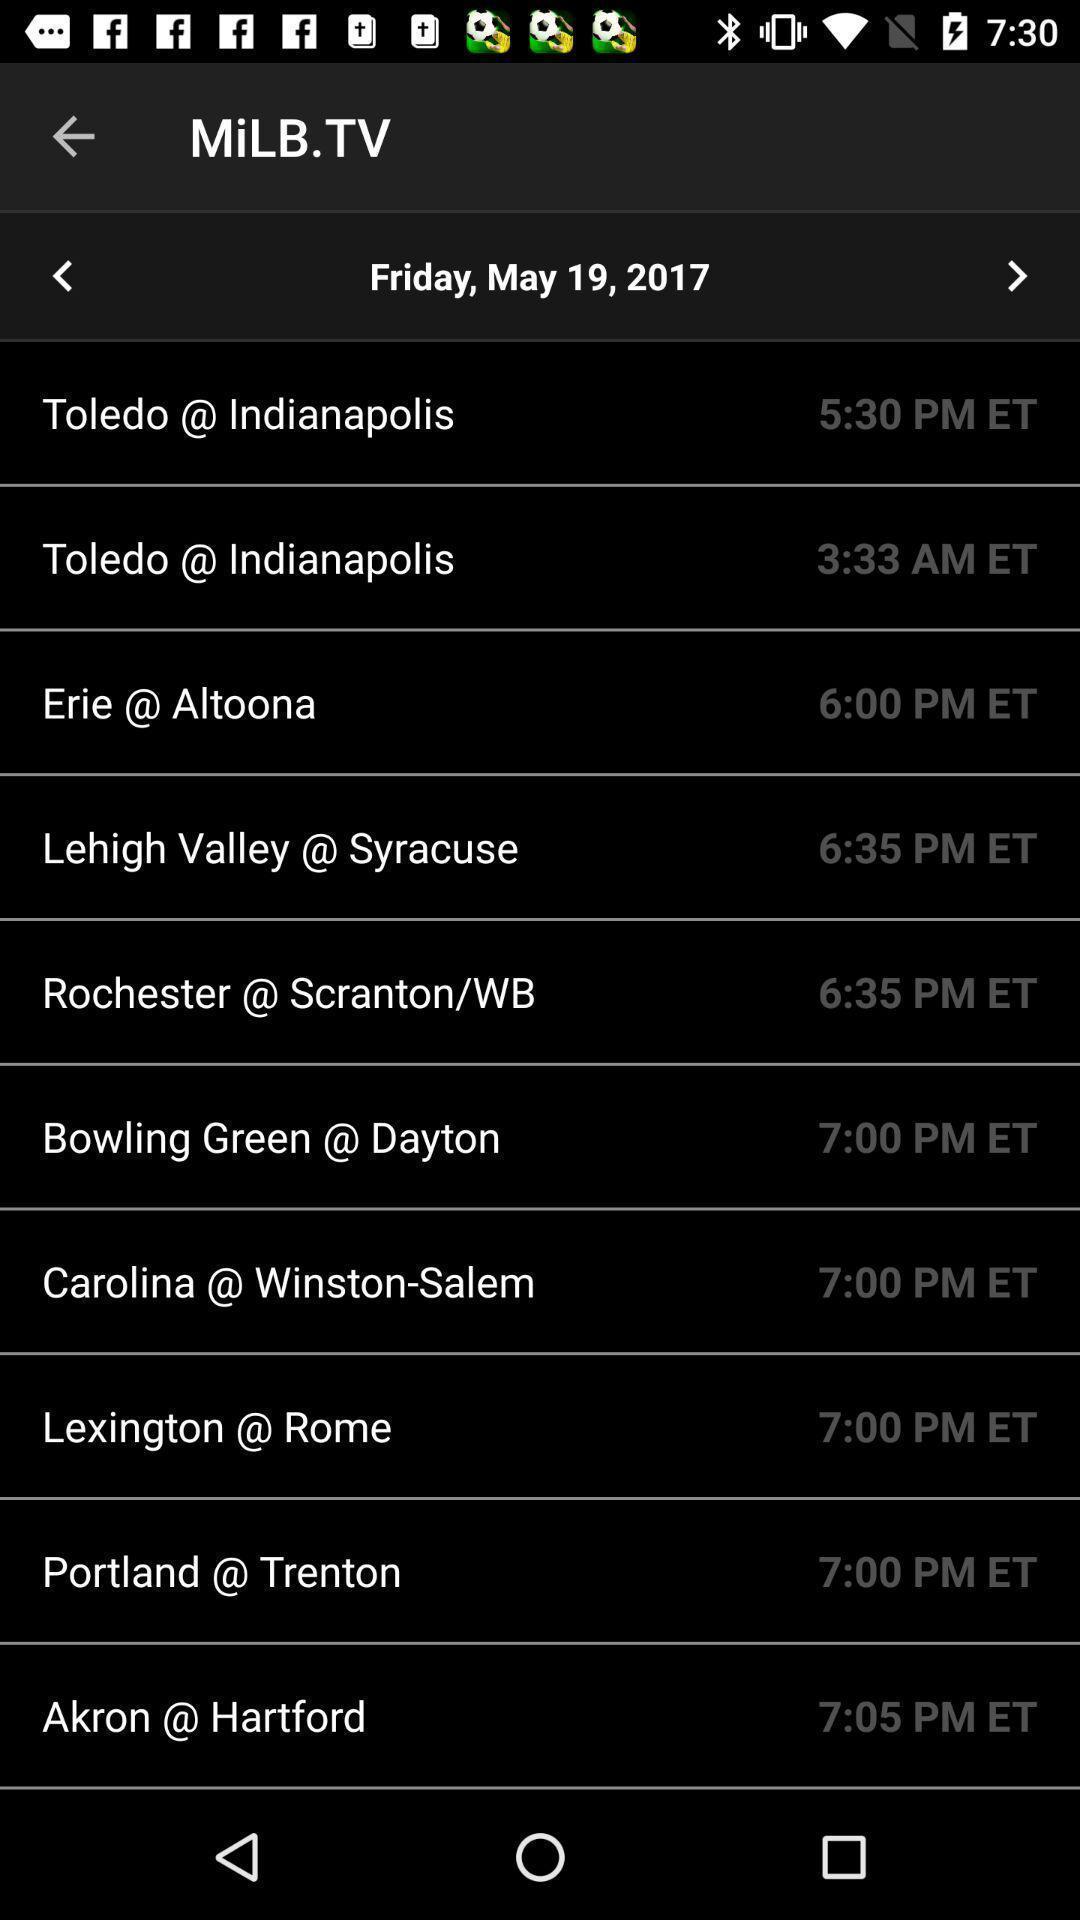What is the overall content of this screenshot? Screen showing multiple actions. 